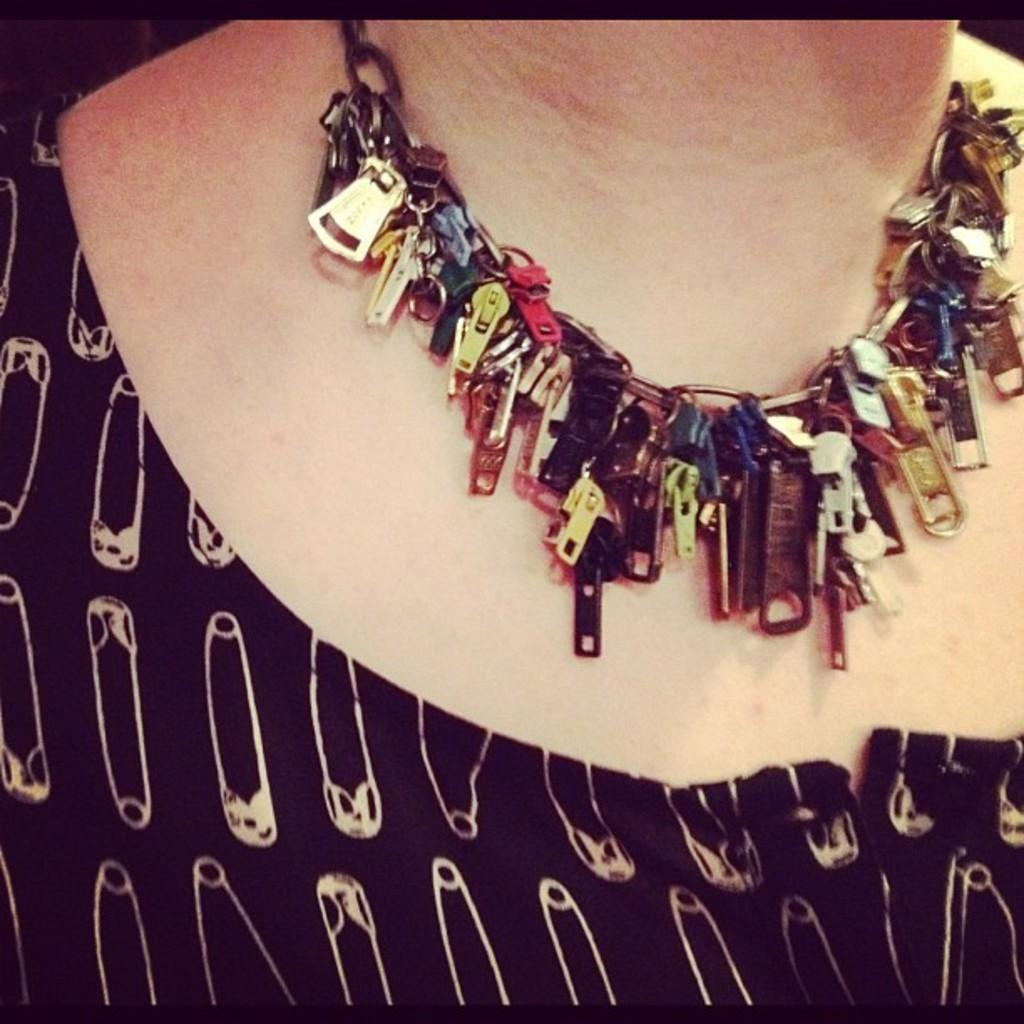What is the main subject of the image? There is a person in the image. Can you describe any accessories the person is wearing? The person is wearing a necklace around their neck. What is the rate at which the goldfish is swimming in the image? There is no goldfish present in the image, so it is not possible to determine the rate at which it might be swimming. 